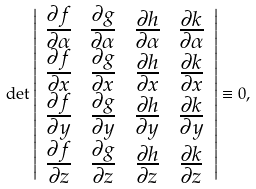<formula> <loc_0><loc_0><loc_500><loc_500>\det \left | \begin{array} { c c c c } \frac { \partial f } { \partial \alpha } & \frac { \partial g } { \partial \alpha } & \frac { \partial h } { \partial \alpha } & \frac { \partial k } { \partial \alpha } \\ \frac { \partial f } { \partial x } & \frac { \partial g } { \partial x } & \frac { \partial h } { \partial x } & \frac { \partial k } { \partial x } \\ \frac { \partial f } { \partial y } & \frac { \partial g } { \partial y } & \frac { \partial h } { \partial y } & \frac { \partial k } { \partial y } \\ \frac { \partial f } { \partial z } & \frac { \partial g } { \partial z } & \frac { \partial h } { \partial z } & \frac { \partial k } { \partial z } \end{array} \right | \equiv 0 ,</formula> 